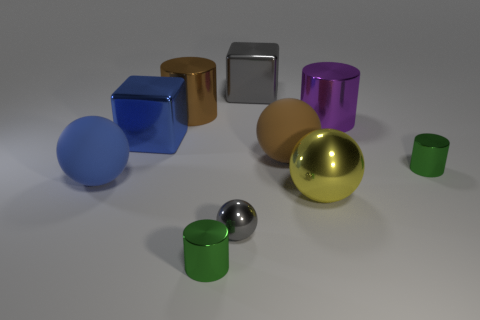Can you describe the lighting and shadows in the scene? The image shows a soft overhead lighting that casts gentle shadows below and to the right of the objects. This lighting helps to accentuate the shapes and textures of the objects and suggests an indoor setting with diffuse light. Does the lighting affect the colors of the objects? Yes, the soft lighting in the image allows the true colors of the objects to be visible without creating harsh reflections or glare. The way light interacts with the objects' surfaces provides a good sense of their material properties. 